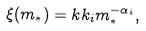Convert formula to latex. <formula><loc_0><loc_0><loc_500><loc_500>\xi ( m _ { * } ) = k k _ { i } m _ { * } ^ { - \alpha _ { i } } ,</formula> 